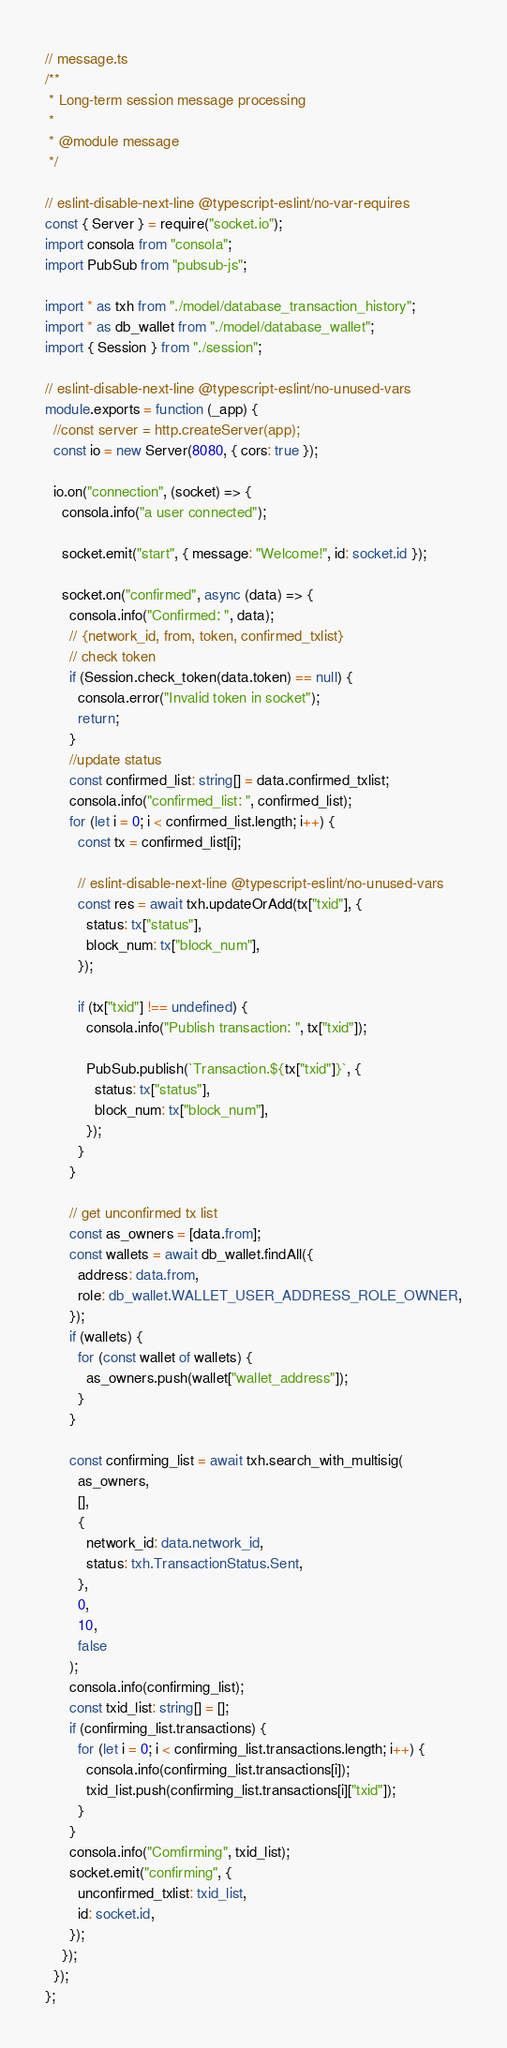Convert code to text. <code><loc_0><loc_0><loc_500><loc_500><_TypeScript_>// message.ts
/**
 * Long-term session message processing
 *
 * @module message
 */

// eslint-disable-next-line @typescript-eslint/no-var-requires
const { Server } = require("socket.io");
import consola from "consola";
import PubSub from "pubsub-js";

import * as txh from "./model/database_transaction_history";
import * as db_wallet from "./model/database_wallet";
import { Session } from "./session";

// eslint-disable-next-line @typescript-eslint/no-unused-vars
module.exports = function (_app) {
  //const server = http.createServer(app);
  const io = new Server(8080, { cors: true });

  io.on("connection", (socket) => {
    consola.info("a user connected");

    socket.emit("start", { message: "Welcome!", id: socket.id });

    socket.on("confirmed", async (data) => {
      consola.info("Confirmed: ", data);
      // {network_id, from, token, confirmed_txlist}
      // check token
      if (Session.check_token(data.token) == null) {
        consola.error("Invalid token in socket");
        return;
      }
      //update status
      const confirmed_list: string[] = data.confirmed_txlist;
      consola.info("confirmed_list: ", confirmed_list);
      for (let i = 0; i < confirmed_list.length; i++) {
        const tx = confirmed_list[i];

        // eslint-disable-next-line @typescript-eslint/no-unused-vars
        const res = await txh.updateOrAdd(tx["txid"], {
          status: tx["status"],
          block_num: tx["block_num"],
        });

        if (tx["txid"] !== undefined) {
          consola.info("Publish transaction: ", tx["txid"]);

          PubSub.publish(`Transaction.${tx["txid"]}`, {
            status: tx["status"],
            block_num: tx["block_num"],
          });
        }
      }

      // get unconfirmed tx list
      const as_owners = [data.from];
      const wallets = await db_wallet.findAll({
        address: data.from,
        role: db_wallet.WALLET_USER_ADDRESS_ROLE_OWNER,
      });
      if (wallets) {
        for (const wallet of wallets) {
          as_owners.push(wallet["wallet_address"]);
        }
      }

      const confirming_list = await txh.search_with_multisig(
        as_owners,
        [],
        {
          network_id: data.network_id,
          status: txh.TransactionStatus.Sent,
        },
        0,
        10,
        false
      );
      consola.info(confirming_list);
      const txid_list: string[] = [];
      if (confirming_list.transactions) {
        for (let i = 0; i < confirming_list.transactions.length; i++) {
          consola.info(confirming_list.transactions[i]);
          txid_list.push(confirming_list.transactions[i]["txid"]);
        }
      }
      consola.info("Comfirming", txid_list);
      socket.emit("confirming", {
        unconfirmed_txlist: txid_list,
        id: socket.id,
      });
    });
  });
};
</code> 